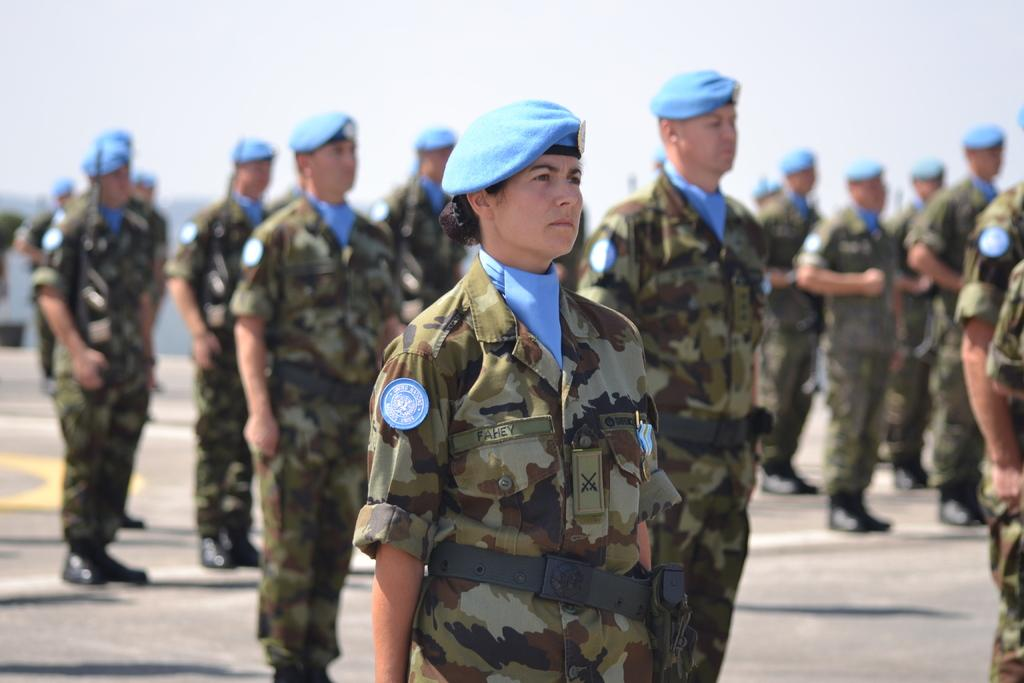Who is the main subject in the image? There is a woman in the middle of the image. What is the woman wearing? The woman is wearing a dress and a cap. What can be seen in the background of the image? There is a group of men in the background of the image. What is visible at the top of the image? The sky is visible at the top of the image. How many eyes does the woman have in the image? The number of eyes cannot be determined from the image, as it only shows the woman from the front and does not provide a clear view of her eyes. 